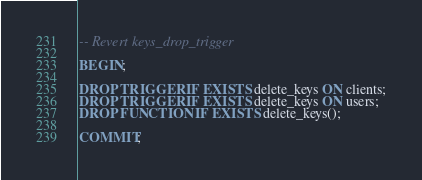<code> <loc_0><loc_0><loc_500><loc_500><_SQL_>-- Revert keys_drop_trigger

BEGIN;

DROP TRIGGER IF EXISTS delete_keys ON clients;
DROP TRIGGER IF EXISTS delete_keys ON users;
DROP FUNCTION IF EXISTS delete_keys();

COMMIT;
</code> 